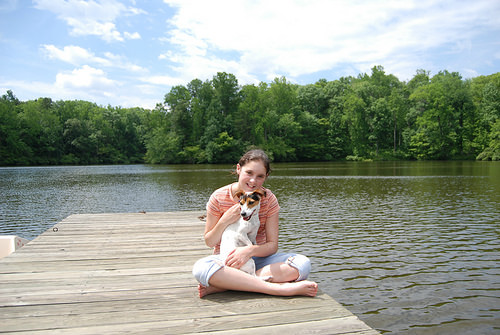<image>
Can you confirm if the dog is under the girl? No. The dog is not positioned under the girl. The vertical relationship between these objects is different. Is there a dog in the water? Yes. The dog is contained within or inside the water, showing a containment relationship. Is there a dog next to the girl? Yes. The dog is positioned adjacent to the girl, located nearby in the same general area. 